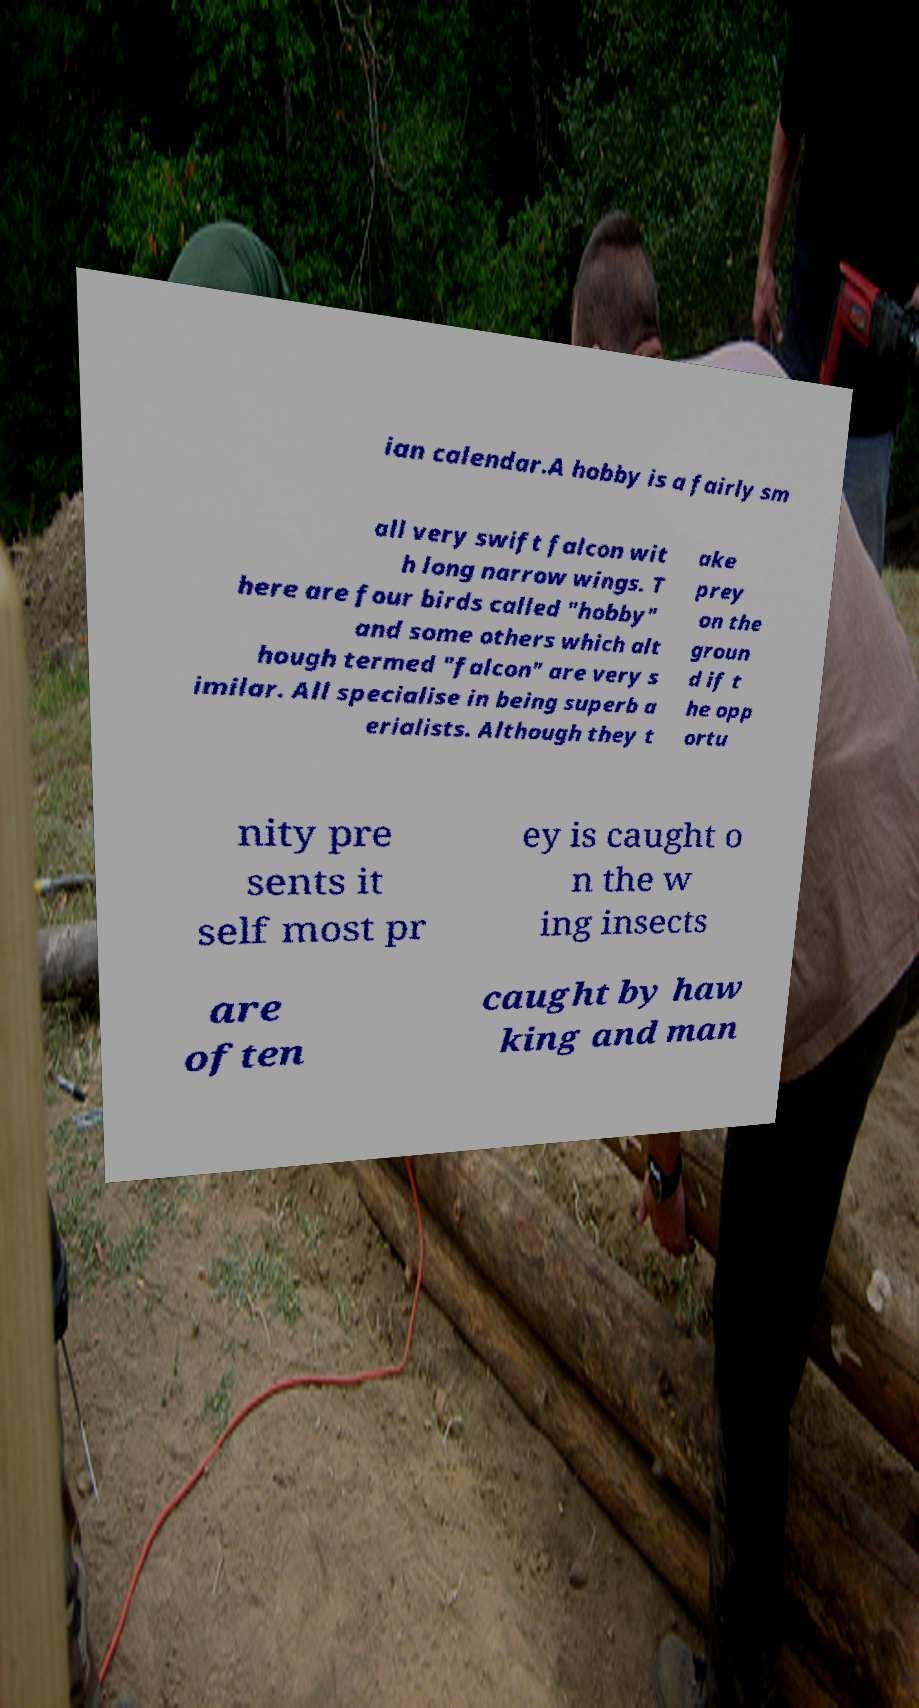Can you read and provide the text displayed in the image?This photo seems to have some interesting text. Can you extract and type it out for me? ian calendar.A hobby is a fairly sm all very swift falcon wit h long narrow wings. T here are four birds called "hobby" and some others which alt hough termed "falcon" are very s imilar. All specialise in being superb a erialists. Although they t ake prey on the groun d if t he opp ortu nity pre sents it self most pr ey is caught o n the w ing insects are often caught by haw king and man 